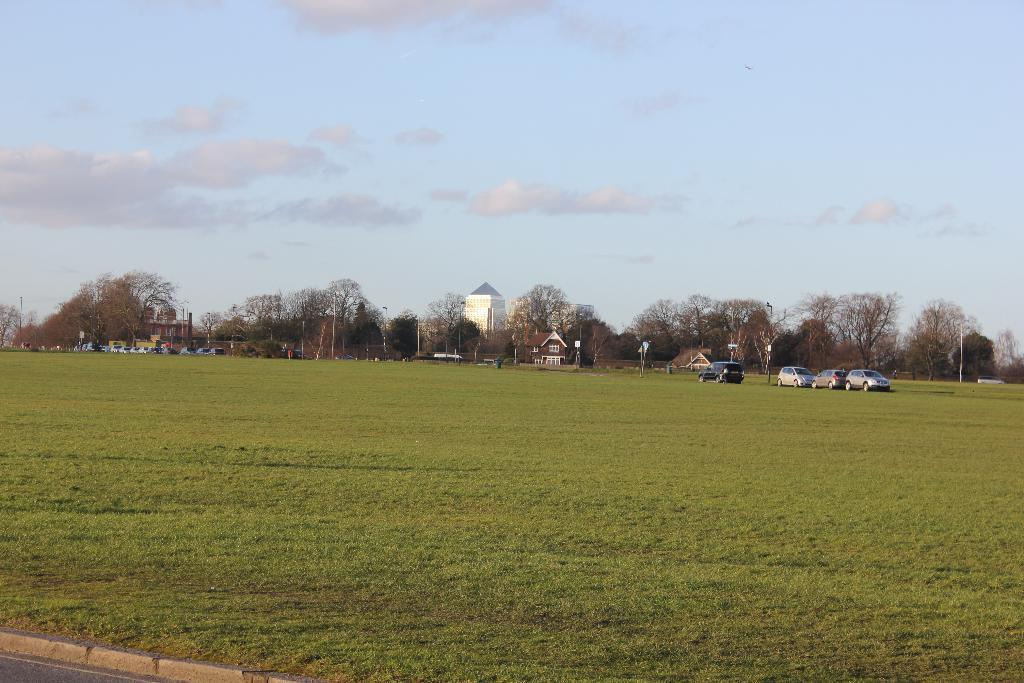What type of structures can be seen in the image? There are buildings in the image. What natural elements are present in the image? There are trees and green grass in the image. What man-made objects can be seen in the image? There are poles and vehicles in the image. What is the color of the sky in the image? The sky is blue and white in color. What theory is being discussed by the trees in the image? There is no discussion or theory present in the image; it features buildings, trees, poles, vehicles, green grass, and a blue and white sky. Can you hear the fang of the vehicle in the image? There is no mention of a fang or any sound in the image; it is a still image with no audio component. 